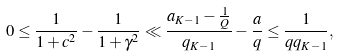Convert formula to latex. <formula><loc_0><loc_0><loc_500><loc_500>0 \leq \frac { 1 } { 1 + c ^ { 2 } } - \frac { 1 } { 1 + \gamma ^ { 2 } } \ll \frac { a _ { K - 1 } - \frac { 1 } { Q } } { q _ { K - 1 } } - \frac { a } { q } \leq \frac { 1 } { q q _ { K - 1 } } ,</formula> 